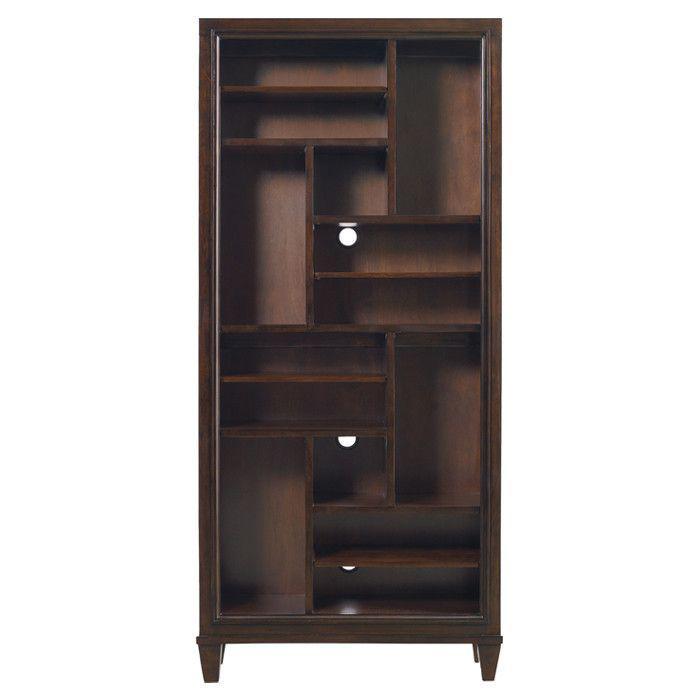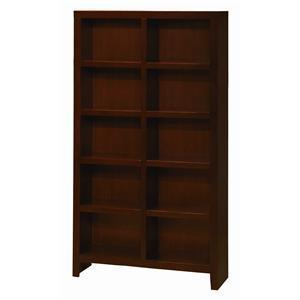The first image is the image on the left, the second image is the image on the right. Considering the images on both sides, is "In one image, a bookcase has a drawer in addition to open shelving." valid? Answer yes or no. No. 